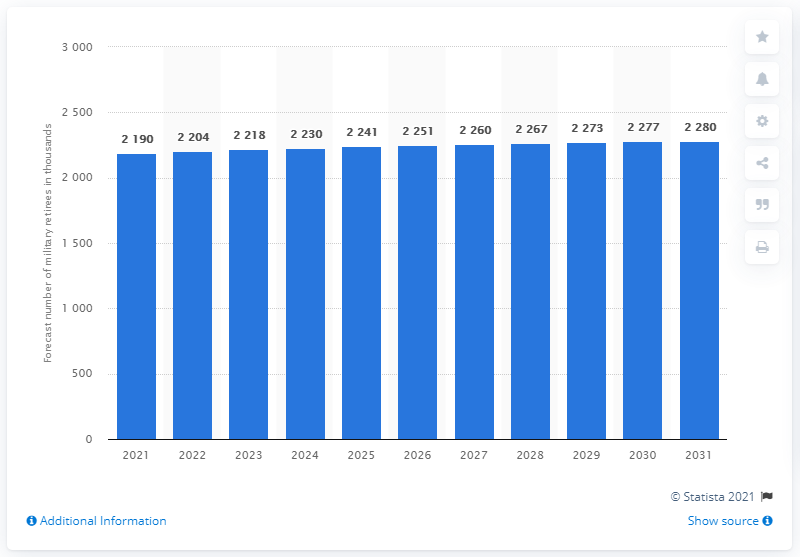Point out several critical features in this image. In the year 2021, there were 219 million military retirees in the United States. 